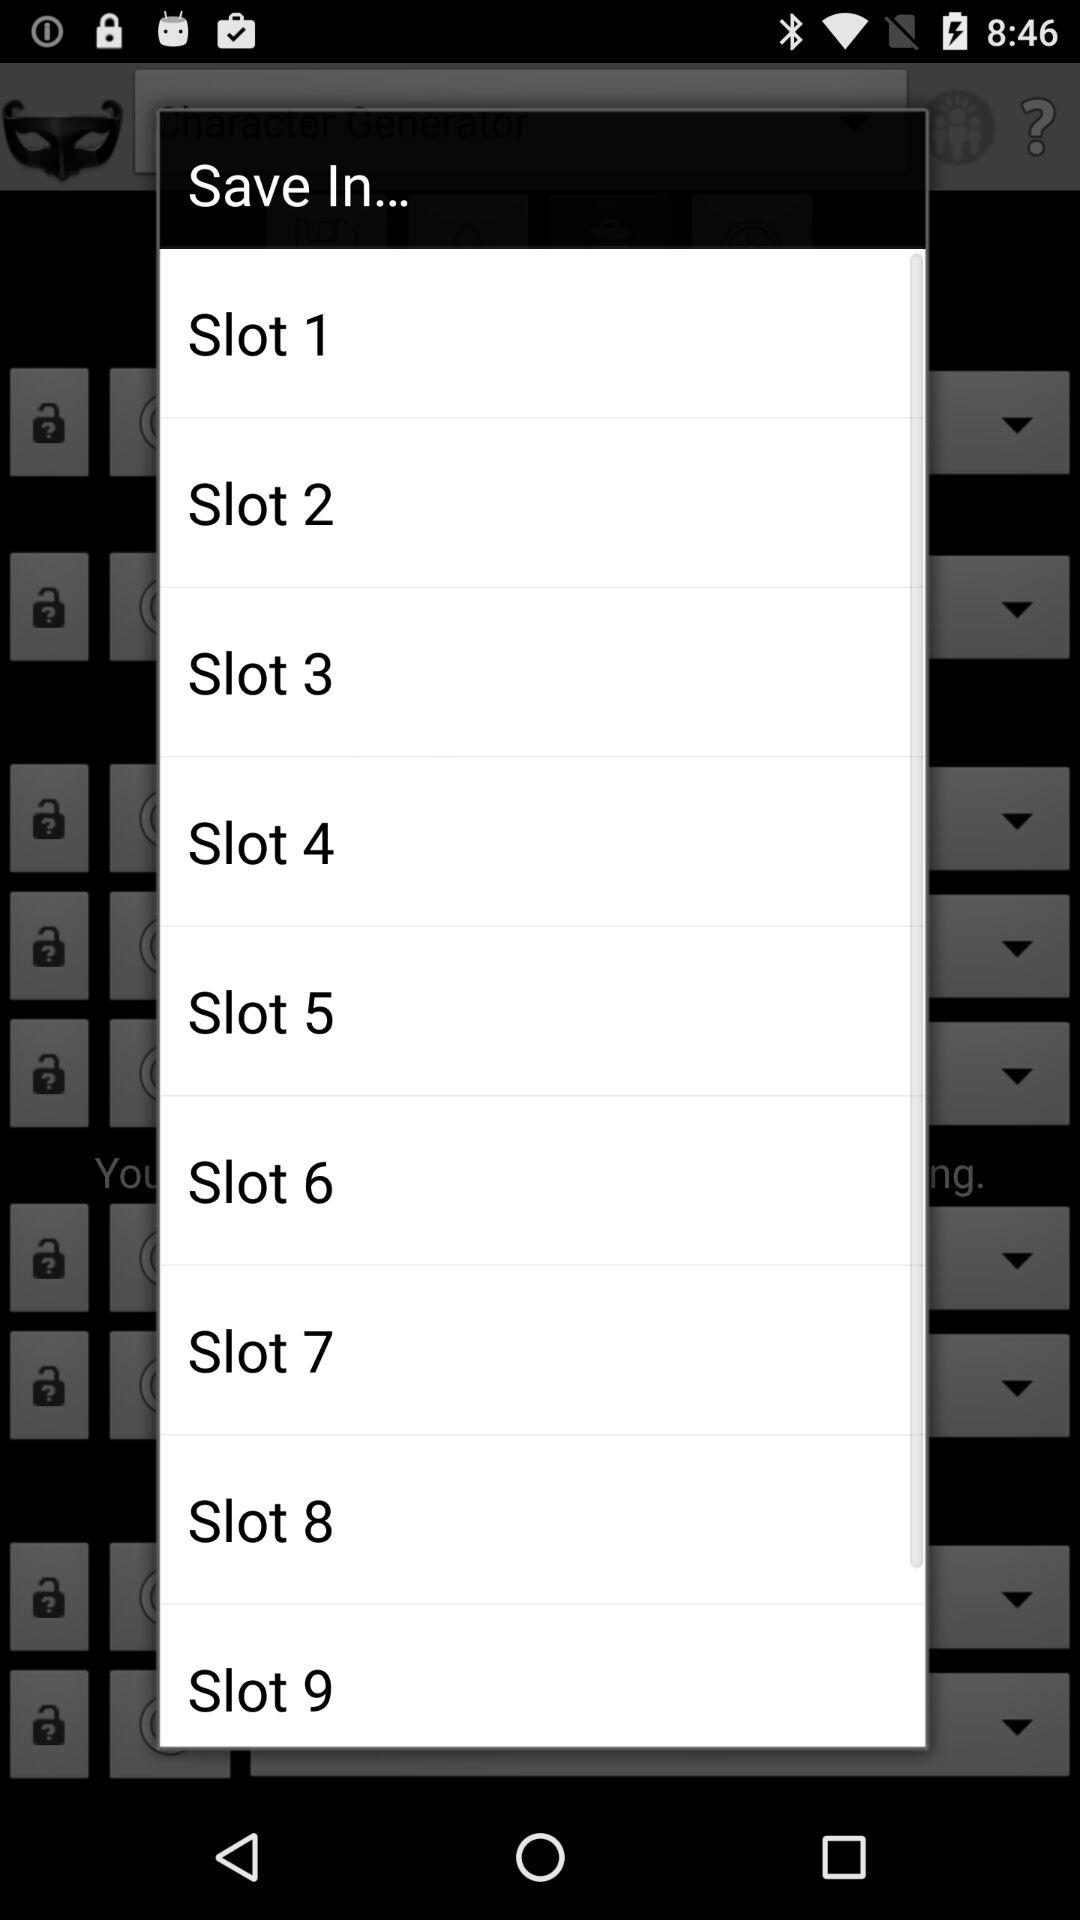What is the minimum number of slots?
When the provided information is insufficient, respond with <no answer>. <no answer> 